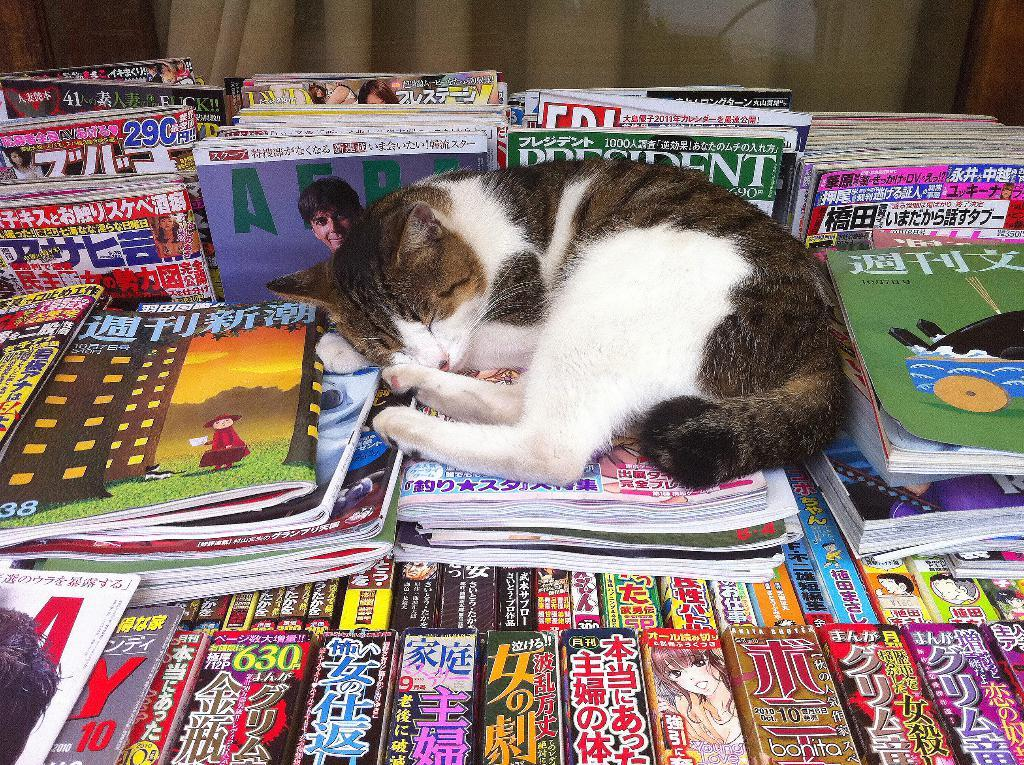What type of animal is present in the image? There is a cat in the image. What is the cat doing in the image? The cat is sleeping. What is the cat sleeping on in the image? The cat is sleeping on books. How are the books arranged in the image? There are many books arranged in the image. What type of crack can be seen in the image? There is no crack present in the image. What disease might the cat be suffering from in the image? There is no indication of any disease in the image; the cat is simply sleeping on books. 